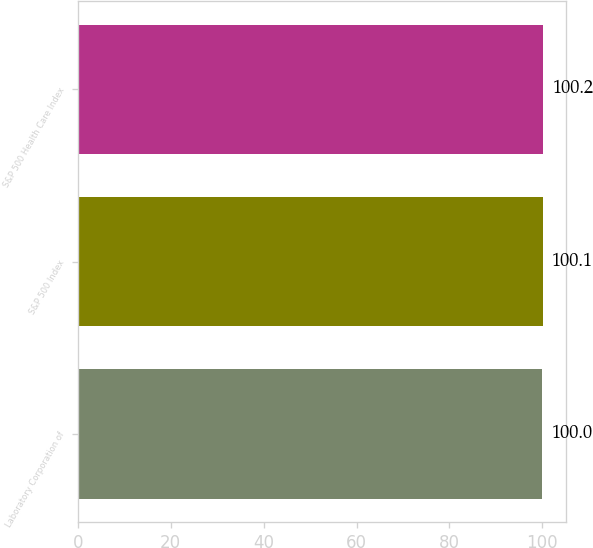Convert chart. <chart><loc_0><loc_0><loc_500><loc_500><bar_chart><fcel>Laboratory Corporation of<fcel>S&P 500 Index<fcel>S&P 500 Health Care Index<nl><fcel>100<fcel>100.1<fcel>100.2<nl></chart> 